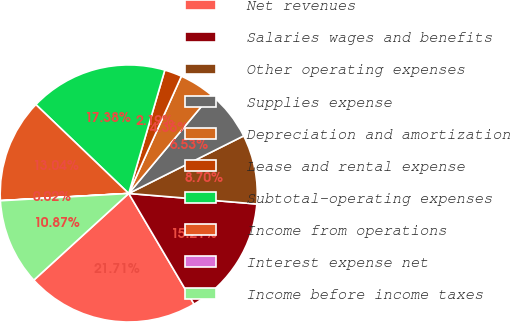Convert chart. <chart><loc_0><loc_0><loc_500><loc_500><pie_chart><fcel>Net revenues<fcel>Salaries wages and benefits<fcel>Other operating expenses<fcel>Supplies expense<fcel>Depreciation and amortization<fcel>Lease and rental expense<fcel>Subtotal-operating expenses<fcel>Income from operations<fcel>Interest expense net<fcel>Income before income taxes<nl><fcel>21.71%<fcel>15.21%<fcel>8.7%<fcel>6.53%<fcel>4.36%<fcel>2.19%<fcel>17.38%<fcel>13.04%<fcel>0.02%<fcel>10.87%<nl></chart> 